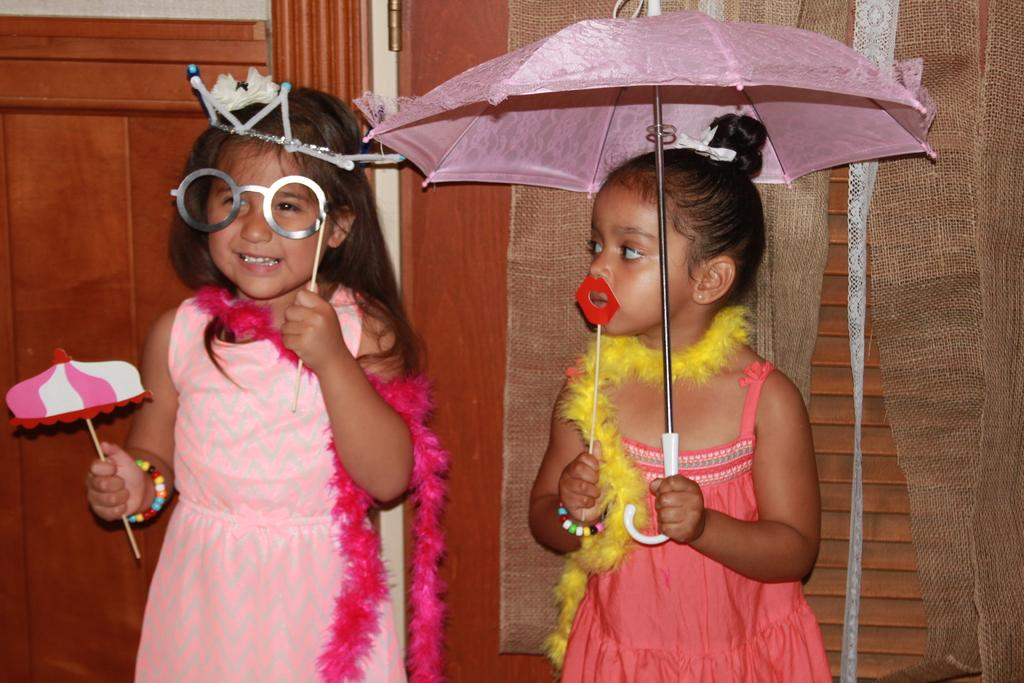What is the girl on the left side of the image holding? The girl on the left side of the image is holding a toy. What is the girl on the right side of the image holding? The girl on the right side of the image is holding an umbrella. What can be seen in the background of the image? There is a wooden door in the background of the image. What type of coat is the goldfish wearing in the image? There is no goldfish present in the image, and therefore no coat can be observed. 